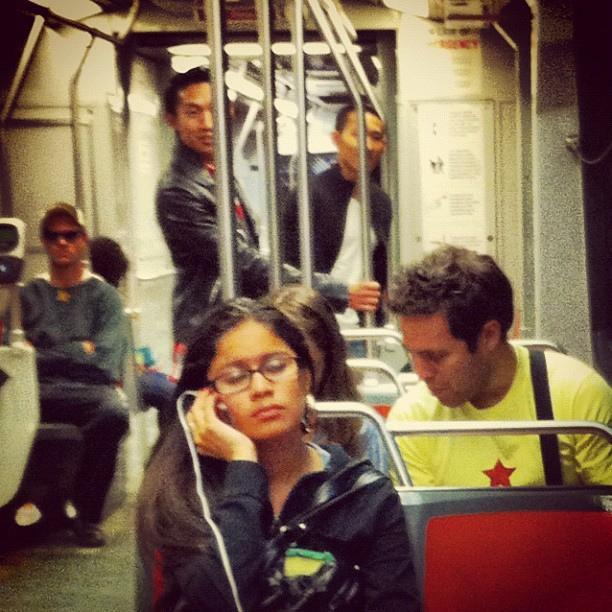How many people are visible?
Give a very brief answer. 6. 